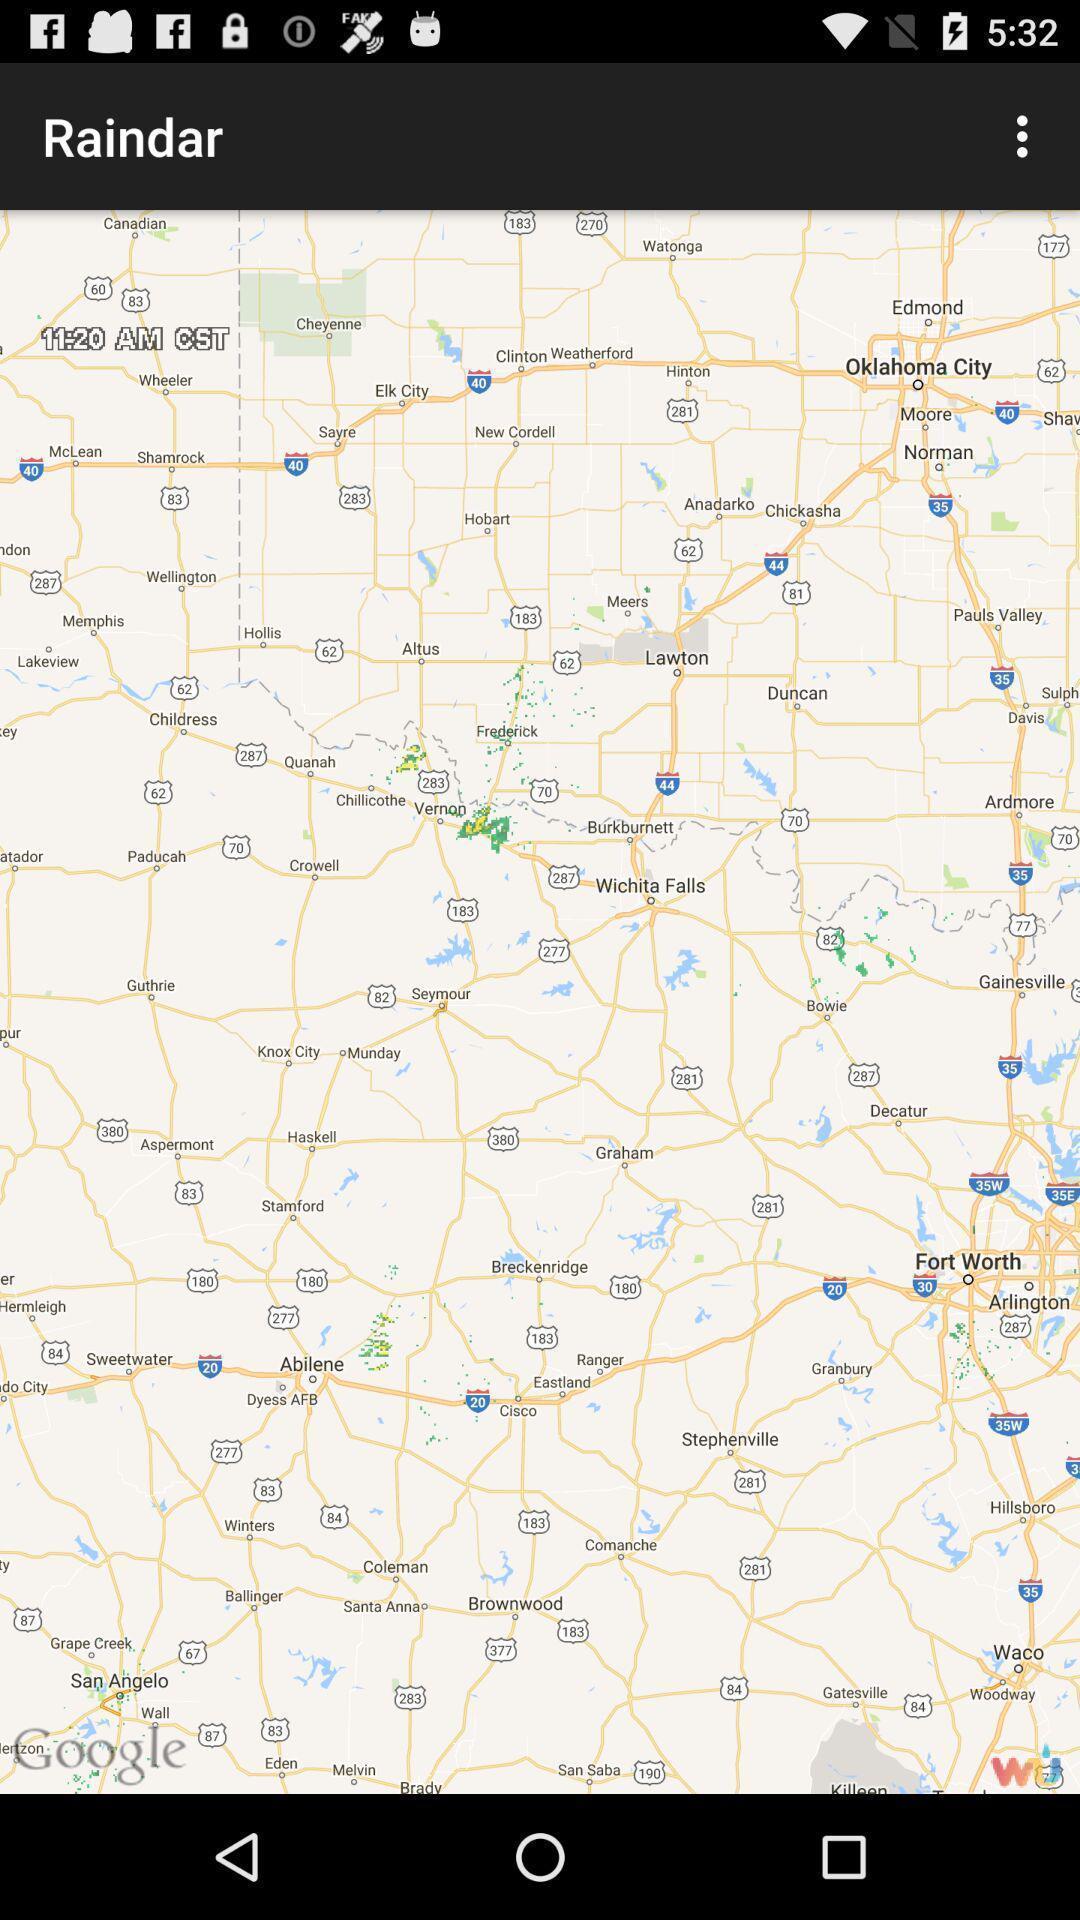Provide a detailed account of this screenshot. Page showing map of a place. 